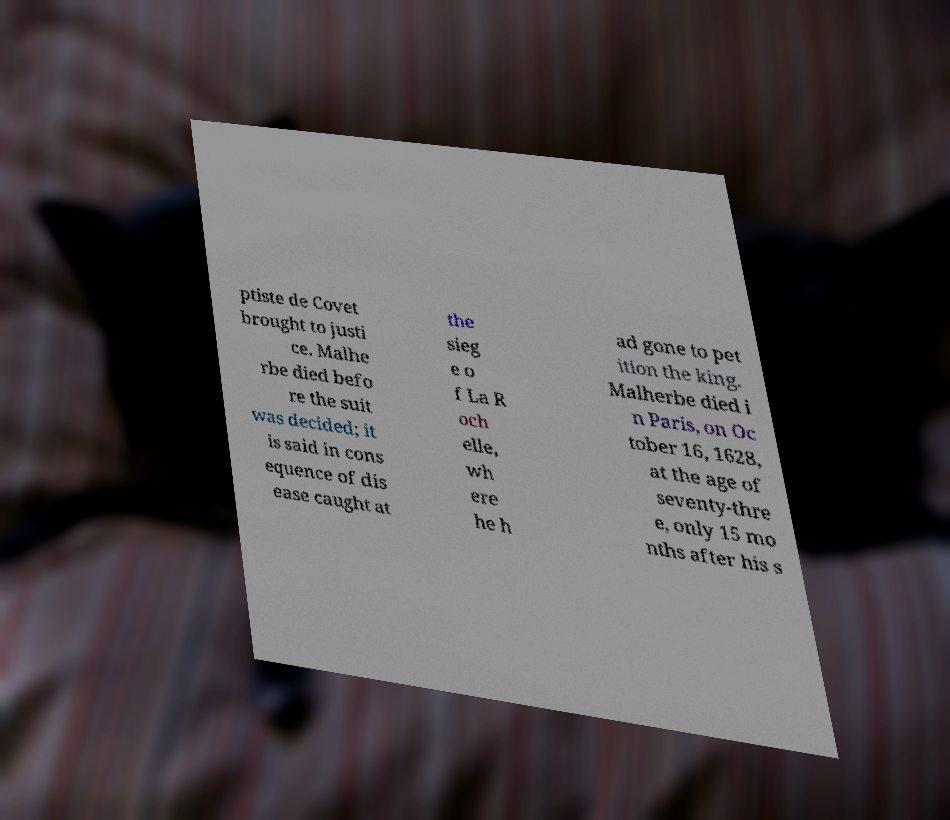Please identify and transcribe the text found in this image. ptiste de Covet brought to justi ce. Malhe rbe died befo re the suit was decided; it is said in cons equence of dis ease caught at the sieg e o f La R och elle, wh ere he h ad gone to pet ition the king. Malherbe died i n Paris, on Oc tober 16, 1628, at the age of seventy-thre e, only 15 mo nths after his s 